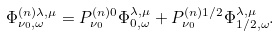<formula> <loc_0><loc_0><loc_500><loc_500>\Phi _ { \nu _ { 0 } , \omega } ^ { ( n ) \lambda , \mu } = P ^ { ( n ) 0 } _ { \nu _ { 0 } } \Phi _ { 0 , \omega } ^ { \lambda , \mu } + P ^ { ( n ) 1 / 2 } _ { \nu _ { 0 } } \Phi _ { 1 / 2 , \omega } ^ { \lambda , \mu } .</formula> 